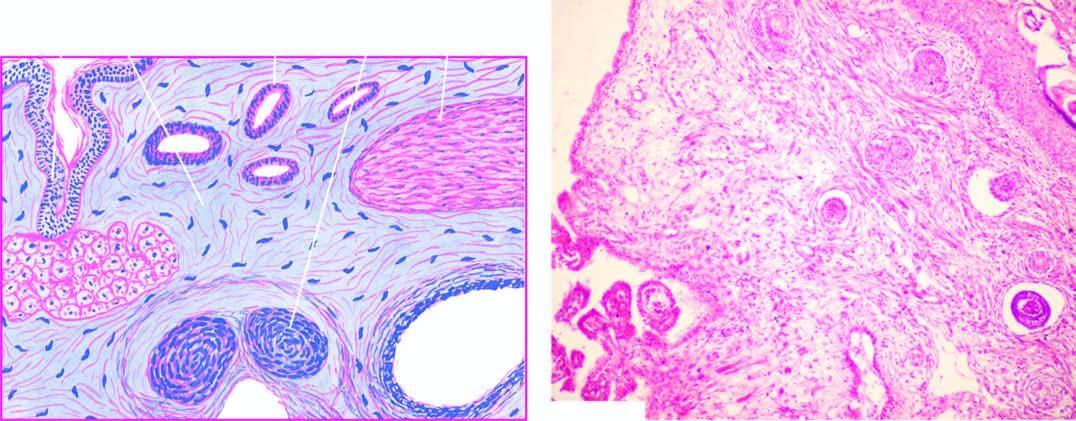does the scarred area show a variety of incompletely differentiated tissue elements?
Answer the question using a single word or phrase. No 